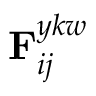Convert formula to latex. <formula><loc_0><loc_0><loc_500><loc_500>{ { F } _ { i j } ^ { y k w } }</formula> 